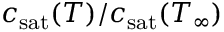Convert formula to latex. <formula><loc_0><loc_0><loc_500><loc_500>c _ { s a t } ( T ) / c _ { s a t } ( T _ { \infty } )</formula> 